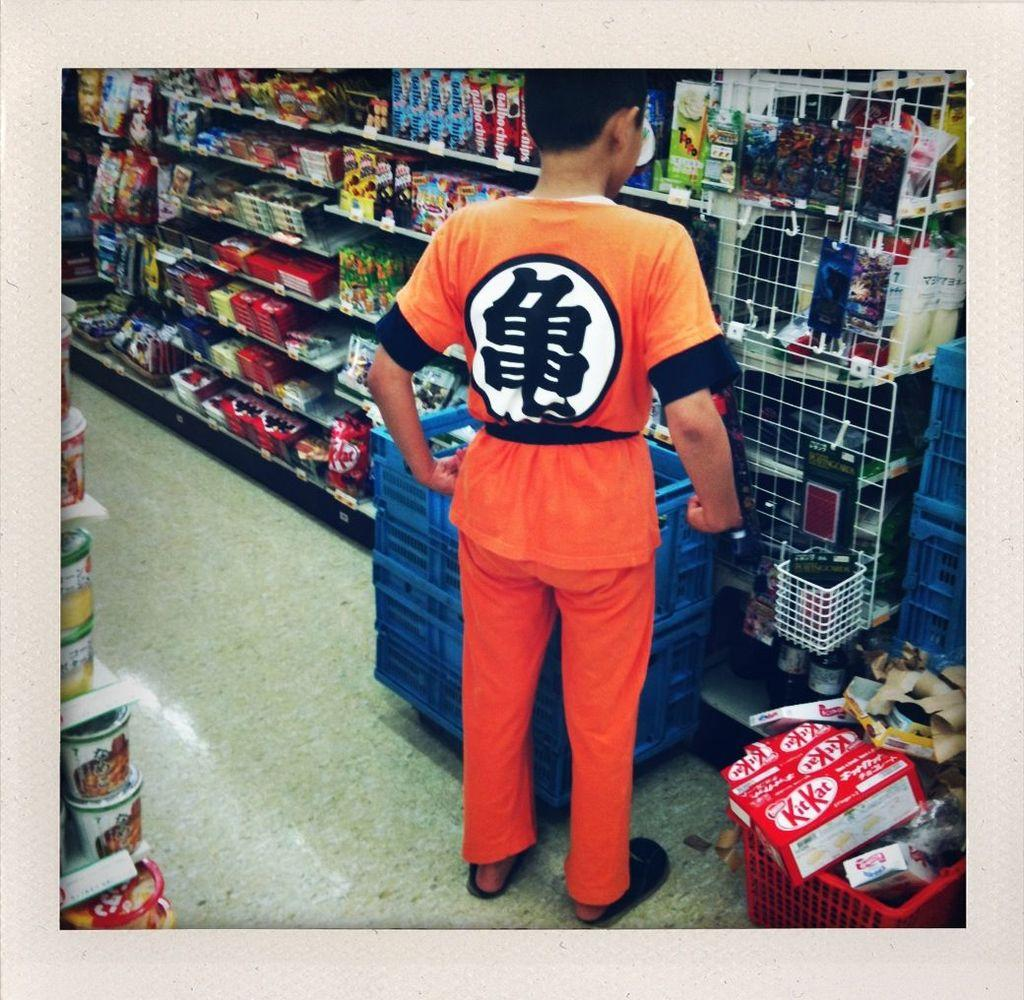<image>
Render a clear and concise summary of the photo. A boy in orange strolls a store aisle with Kit Kats in his basket 